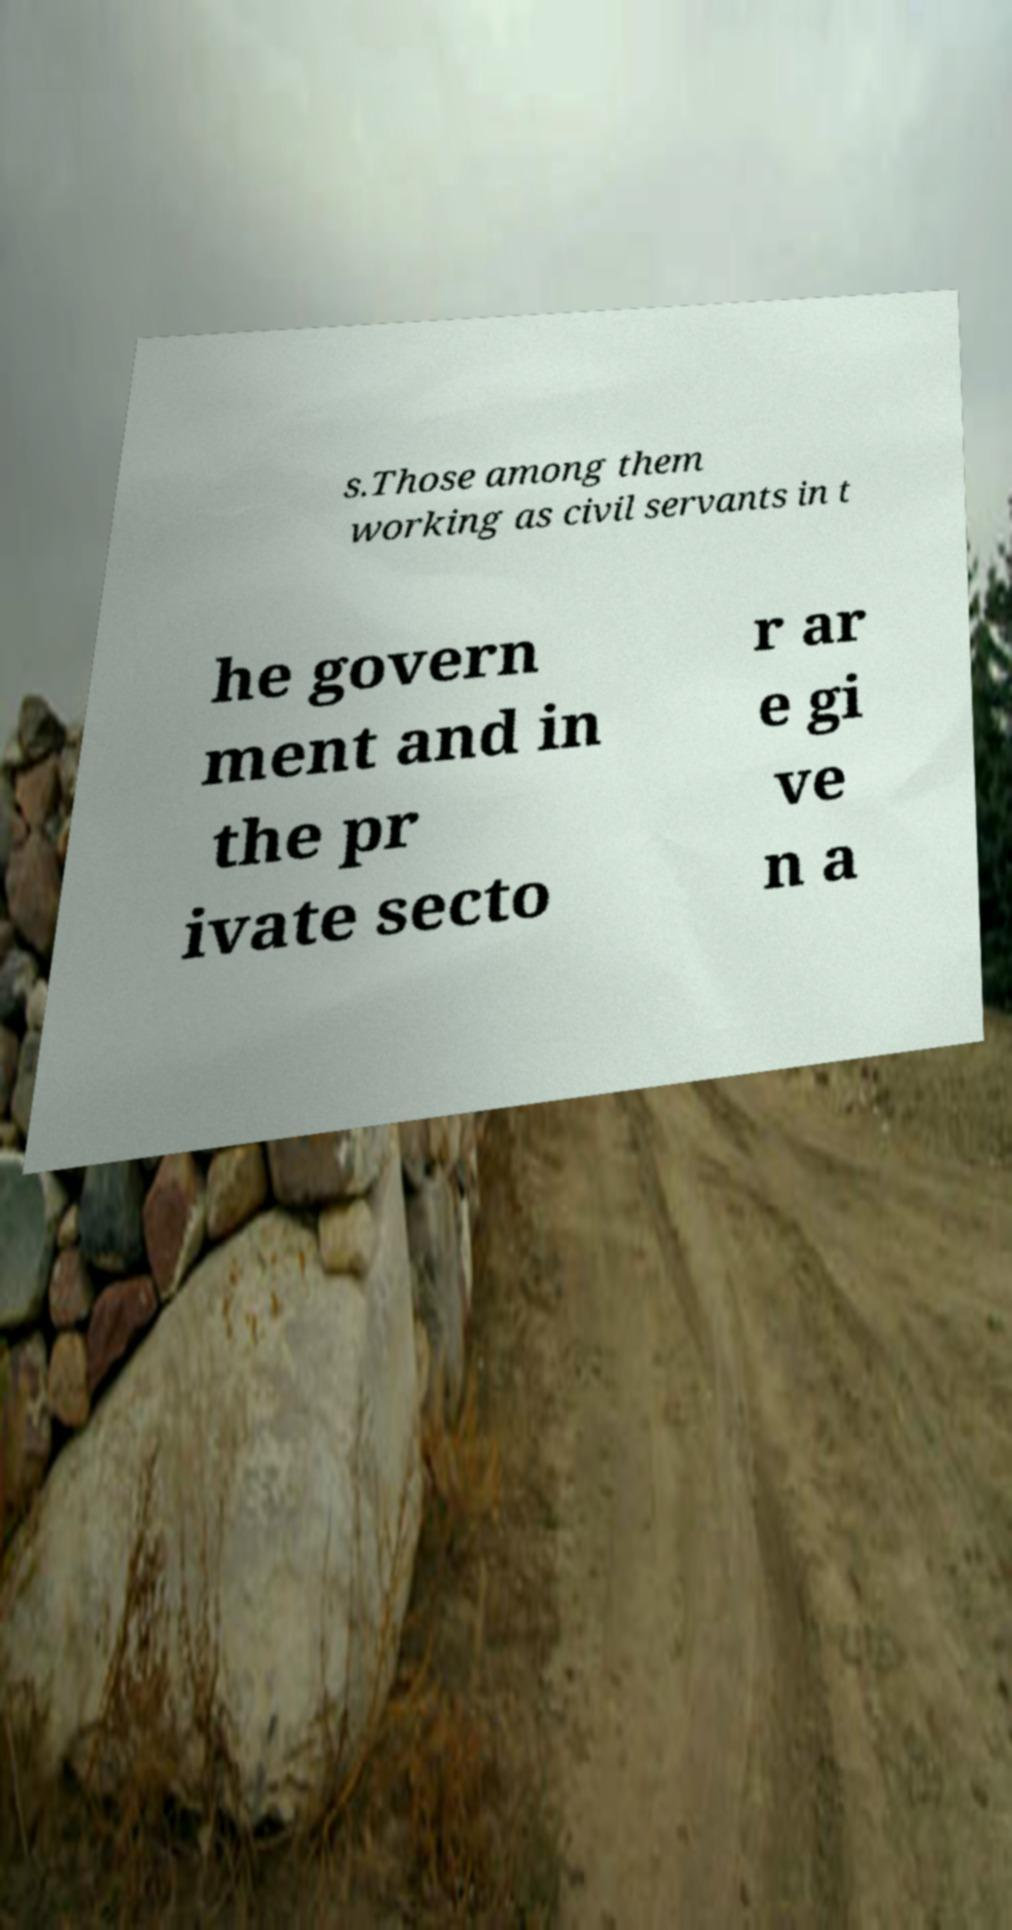Could you assist in decoding the text presented in this image and type it out clearly? s.Those among them working as civil servants in t he govern ment and in the pr ivate secto r ar e gi ve n a 